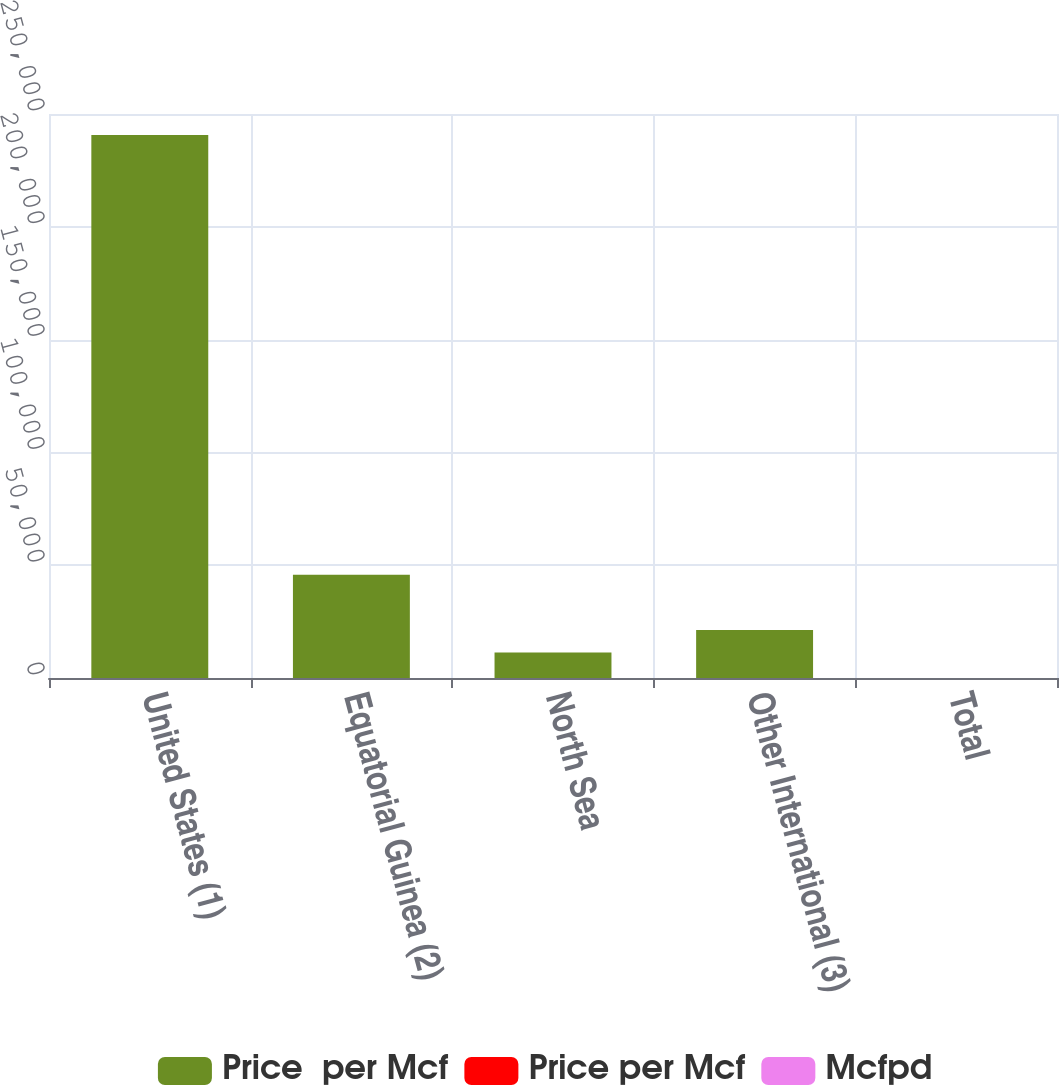Convert chart to OTSL. <chart><loc_0><loc_0><loc_500><loc_500><stacked_bar_chart><ecel><fcel>United States (1)<fcel>Equatorial Guinea (2)<fcel>North Sea<fcel>Other International (3)<fcel>Total<nl><fcel>Price  per Mcf<fcel>240647<fcel>45755<fcel>11286<fcel>21262<fcel>3.985<nl><fcel>Price per Mcf<fcel>6<fcel>0.25<fcel>4.73<fcel>0.75<fcel>4.74<nl><fcel>Mcfpd<fcel>3.24<fcel>0.25<fcel>3.14<fcel>0.38<fcel>2.89<nl></chart> 